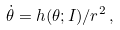Convert formula to latex. <formula><loc_0><loc_0><loc_500><loc_500>\dot { \theta } = h ( \theta ; I ) / r ^ { 2 } \, ,</formula> 